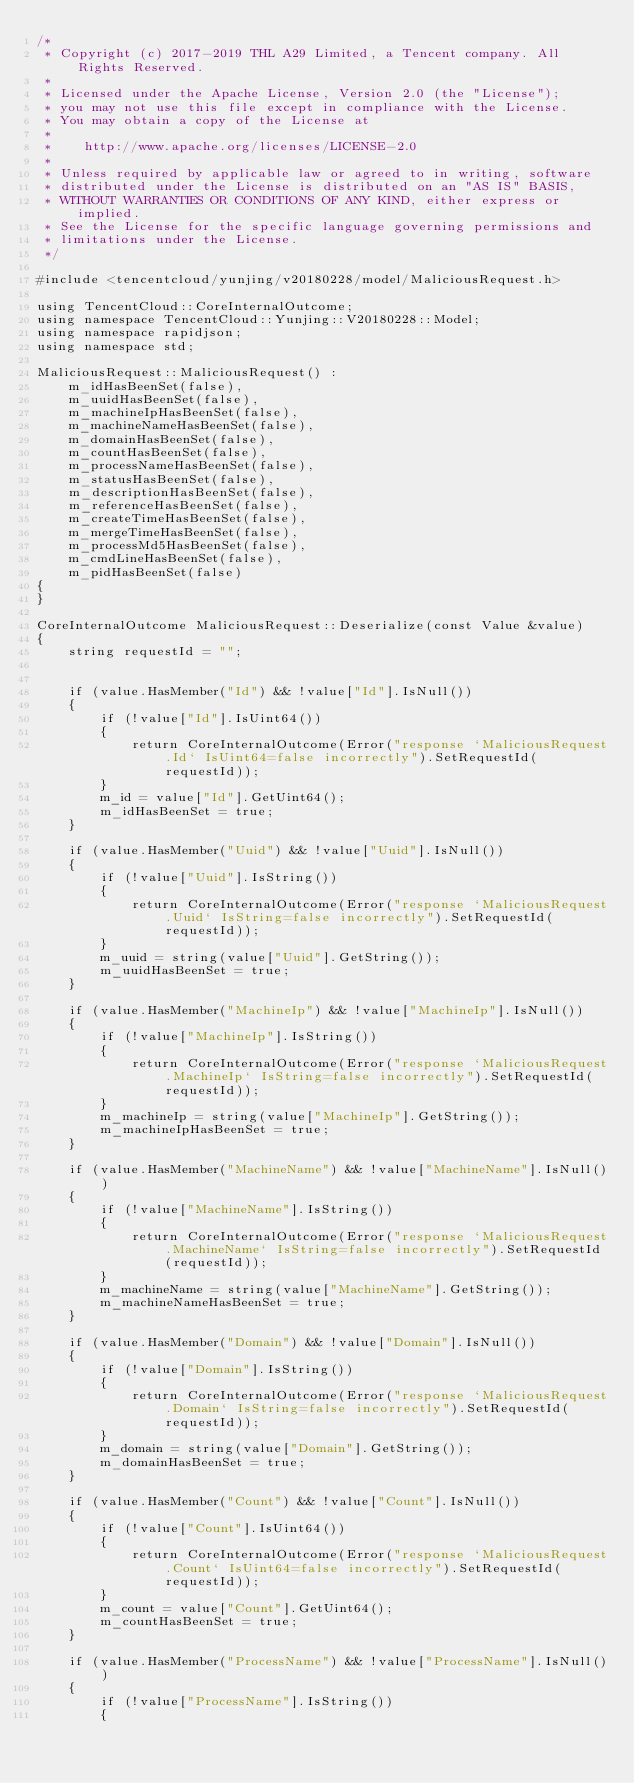Convert code to text. <code><loc_0><loc_0><loc_500><loc_500><_C++_>/*
 * Copyright (c) 2017-2019 THL A29 Limited, a Tencent company. All Rights Reserved.
 *
 * Licensed under the Apache License, Version 2.0 (the "License");
 * you may not use this file except in compliance with the License.
 * You may obtain a copy of the License at
 *
 *    http://www.apache.org/licenses/LICENSE-2.0
 *
 * Unless required by applicable law or agreed to in writing, software
 * distributed under the License is distributed on an "AS IS" BASIS,
 * WITHOUT WARRANTIES OR CONDITIONS OF ANY KIND, either express or implied.
 * See the License for the specific language governing permissions and
 * limitations under the License.
 */

#include <tencentcloud/yunjing/v20180228/model/MaliciousRequest.h>

using TencentCloud::CoreInternalOutcome;
using namespace TencentCloud::Yunjing::V20180228::Model;
using namespace rapidjson;
using namespace std;

MaliciousRequest::MaliciousRequest() :
    m_idHasBeenSet(false),
    m_uuidHasBeenSet(false),
    m_machineIpHasBeenSet(false),
    m_machineNameHasBeenSet(false),
    m_domainHasBeenSet(false),
    m_countHasBeenSet(false),
    m_processNameHasBeenSet(false),
    m_statusHasBeenSet(false),
    m_descriptionHasBeenSet(false),
    m_referenceHasBeenSet(false),
    m_createTimeHasBeenSet(false),
    m_mergeTimeHasBeenSet(false),
    m_processMd5HasBeenSet(false),
    m_cmdLineHasBeenSet(false),
    m_pidHasBeenSet(false)
{
}

CoreInternalOutcome MaliciousRequest::Deserialize(const Value &value)
{
    string requestId = "";


    if (value.HasMember("Id") && !value["Id"].IsNull())
    {
        if (!value["Id"].IsUint64())
        {
            return CoreInternalOutcome(Error("response `MaliciousRequest.Id` IsUint64=false incorrectly").SetRequestId(requestId));
        }
        m_id = value["Id"].GetUint64();
        m_idHasBeenSet = true;
    }

    if (value.HasMember("Uuid") && !value["Uuid"].IsNull())
    {
        if (!value["Uuid"].IsString())
        {
            return CoreInternalOutcome(Error("response `MaliciousRequest.Uuid` IsString=false incorrectly").SetRequestId(requestId));
        }
        m_uuid = string(value["Uuid"].GetString());
        m_uuidHasBeenSet = true;
    }

    if (value.HasMember("MachineIp") && !value["MachineIp"].IsNull())
    {
        if (!value["MachineIp"].IsString())
        {
            return CoreInternalOutcome(Error("response `MaliciousRequest.MachineIp` IsString=false incorrectly").SetRequestId(requestId));
        }
        m_machineIp = string(value["MachineIp"].GetString());
        m_machineIpHasBeenSet = true;
    }

    if (value.HasMember("MachineName") && !value["MachineName"].IsNull())
    {
        if (!value["MachineName"].IsString())
        {
            return CoreInternalOutcome(Error("response `MaliciousRequest.MachineName` IsString=false incorrectly").SetRequestId(requestId));
        }
        m_machineName = string(value["MachineName"].GetString());
        m_machineNameHasBeenSet = true;
    }

    if (value.HasMember("Domain") && !value["Domain"].IsNull())
    {
        if (!value["Domain"].IsString())
        {
            return CoreInternalOutcome(Error("response `MaliciousRequest.Domain` IsString=false incorrectly").SetRequestId(requestId));
        }
        m_domain = string(value["Domain"].GetString());
        m_domainHasBeenSet = true;
    }

    if (value.HasMember("Count") && !value["Count"].IsNull())
    {
        if (!value["Count"].IsUint64())
        {
            return CoreInternalOutcome(Error("response `MaliciousRequest.Count` IsUint64=false incorrectly").SetRequestId(requestId));
        }
        m_count = value["Count"].GetUint64();
        m_countHasBeenSet = true;
    }

    if (value.HasMember("ProcessName") && !value["ProcessName"].IsNull())
    {
        if (!value["ProcessName"].IsString())
        {</code> 